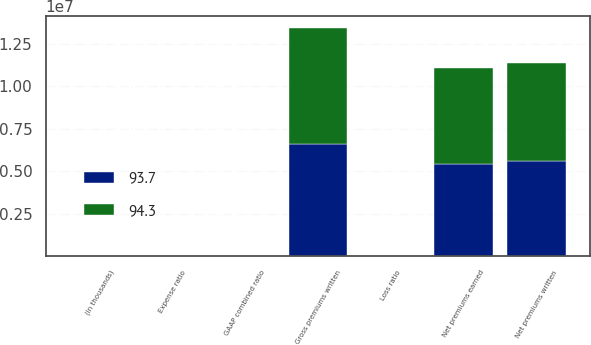<chart> <loc_0><loc_0><loc_500><loc_500><stacked_bar_chart><ecel><fcel>(In thousands)<fcel>Gross premiums written<fcel>Net premiums written<fcel>Net premiums earned<fcel>Loss ratio<fcel>Expense ratio<fcel>GAAP combined ratio<nl><fcel>94.3<fcel>2016<fcel>6.83506e+06<fcel>5.77591e+06<fcel>5.6529e+06<fcel>61<fcel>32.6<fcel>93.6<nl><fcel>93.7<fcel>2015<fcel>6.60749e+06<fcel>5.5914e+06<fcel>5.4315e+06<fcel>60.8<fcel>32.6<fcel>93.4<nl></chart> 